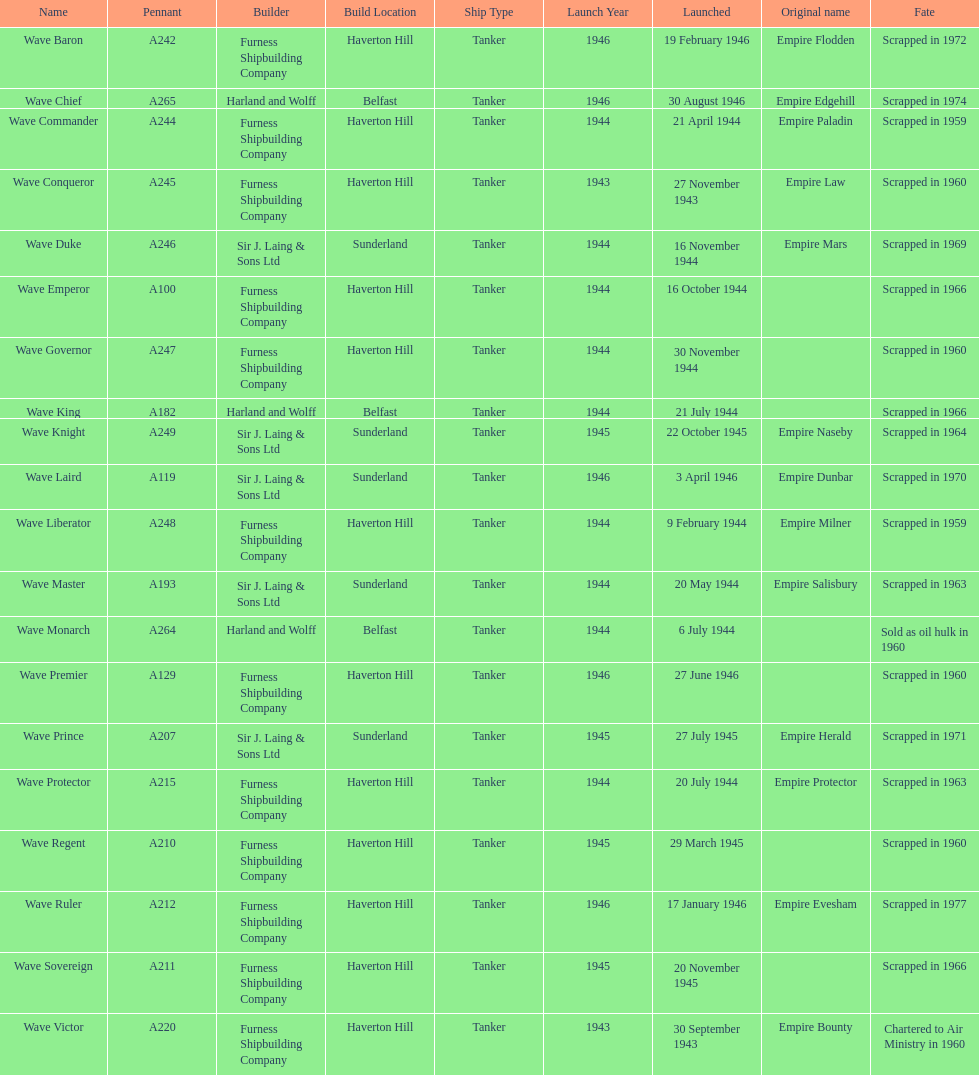Which other ship was launched in the same year as the wave victor? Wave Conqueror. 